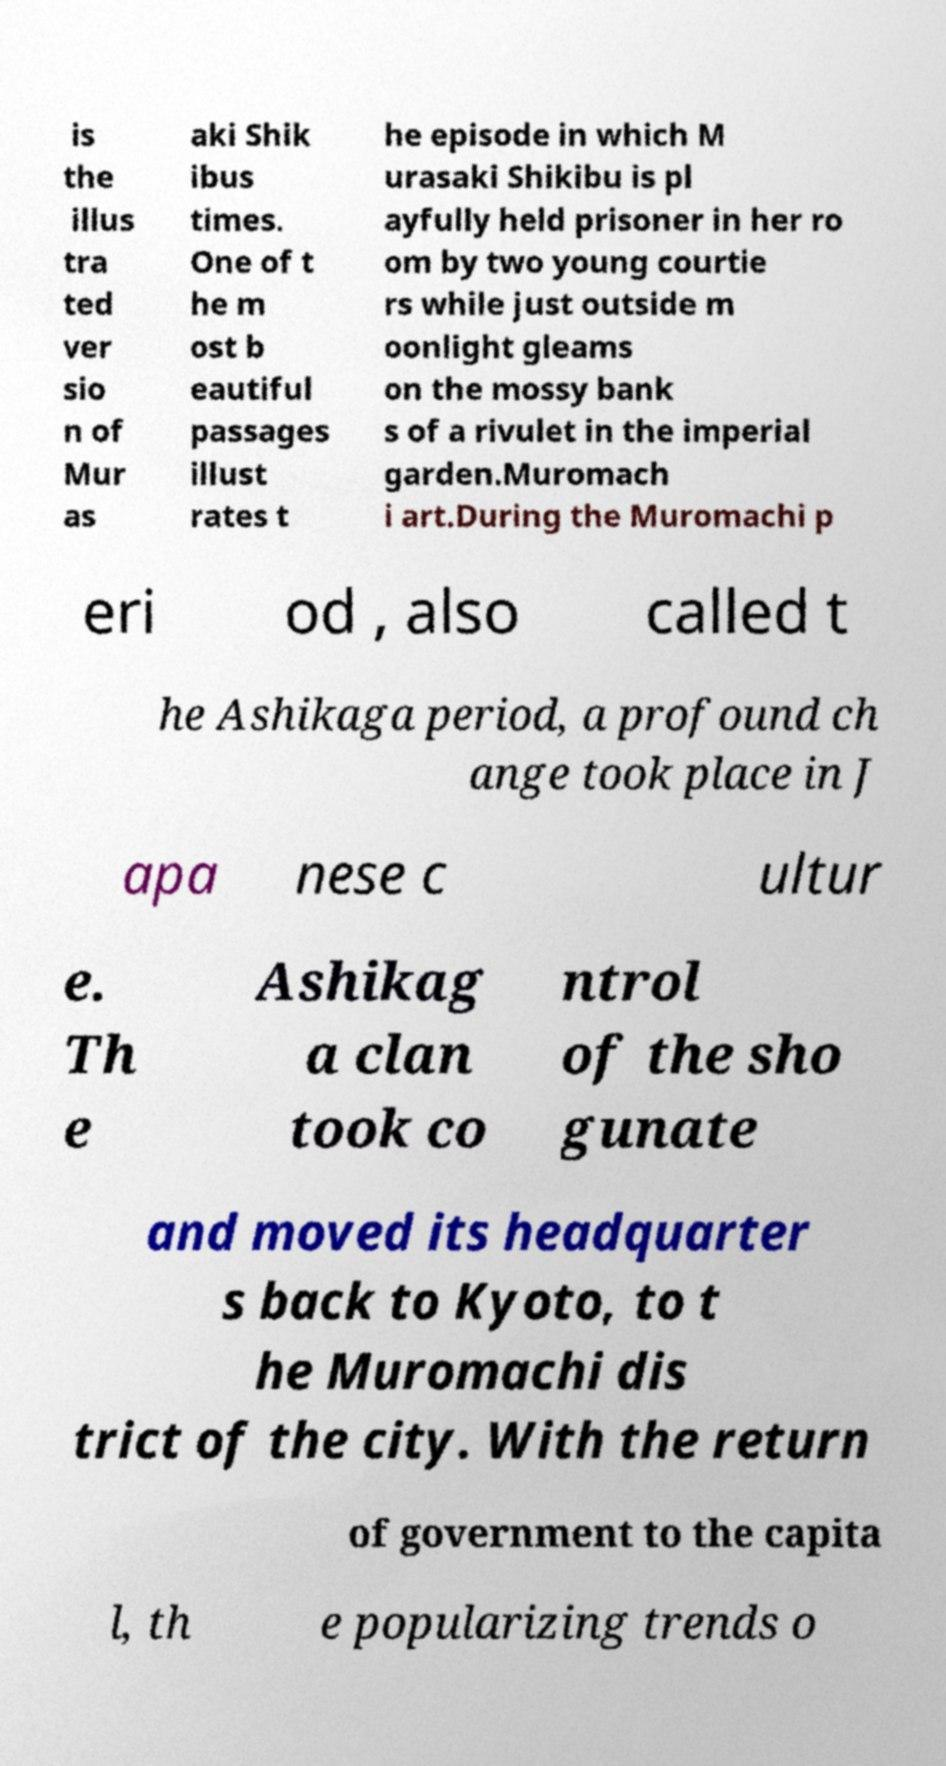Please read and relay the text visible in this image. What does it say? is the illus tra ted ver sio n of Mur as aki Shik ibus times. One of t he m ost b eautiful passages illust rates t he episode in which M urasaki Shikibu is pl ayfully held prisoner in her ro om by two young courtie rs while just outside m oonlight gleams on the mossy bank s of a rivulet in the imperial garden.Muromach i art.During the Muromachi p eri od , also called t he Ashikaga period, a profound ch ange took place in J apa nese c ultur e. Th e Ashikag a clan took co ntrol of the sho gunate and moved its headquarter s back to Kyoto, to t he Muromachi dis trict of the city. With the return of government to the capita l, th e popularizing trends o 